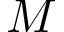Convert formula to latex. <formula><loc_0><loc_0><loc_500><loc_500>M</formula> 